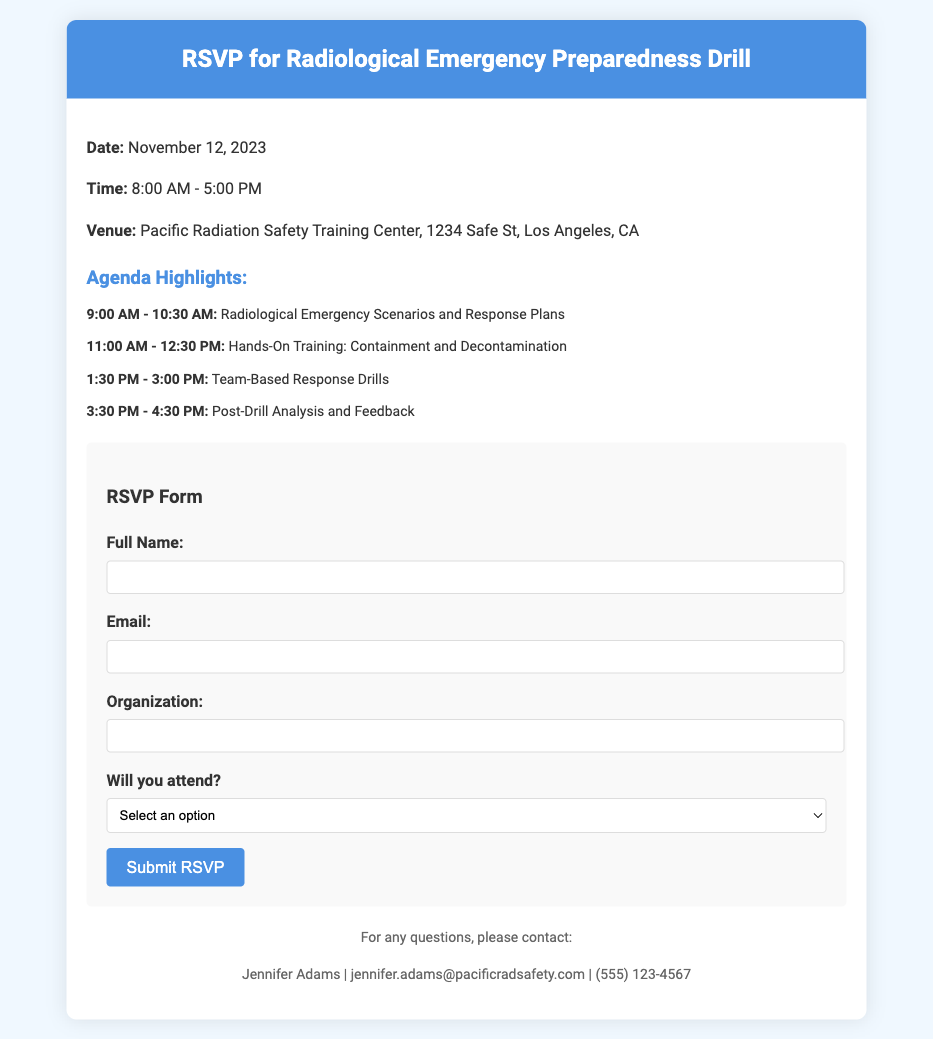What is the date of the drill? The date of the drill is mentioned in the document as November 12, 2023.
Answer: November 12, 2023 What is the location of the event? The venue details provided indicate that the event will be held at the Pacific Radiation Safety Training Center, 1234 Safe St, Los Angeles, CA.
Answer: Pacific Radiation Safety Training Center, 1234 Safe St, Los Angeles, CA What time does the drill start? The document specifies that the drill starts at 8:00 AM.
Answer: 8:00 AM What is the duration of the drill? The drill is scheduled from 8:00 AM to 5:00 PM, indicating that it lasts for 9 hours.
Answer: 9 hours Which session follows the "Hands-On Training: Containment and Decontamination"? The session that follows is "Team-Based Response Drills" scheduled from 1:30 PM to 3:00 PM.
Answer: Team-Based Response Drills Will there be post-drill feedback? Yes, the agenda includes a session titled "Post-Drill Analysis and Feedback."
Answer: Yes What type of form is included in the document? The document includes an RSVP form for attendees to confirm their participation in the drill.
Answer: RSVP form How can I contact someone for questions? Jennifer Adams is the contact person for questions, as stated in the document.
Answer: Jennifer Adams 